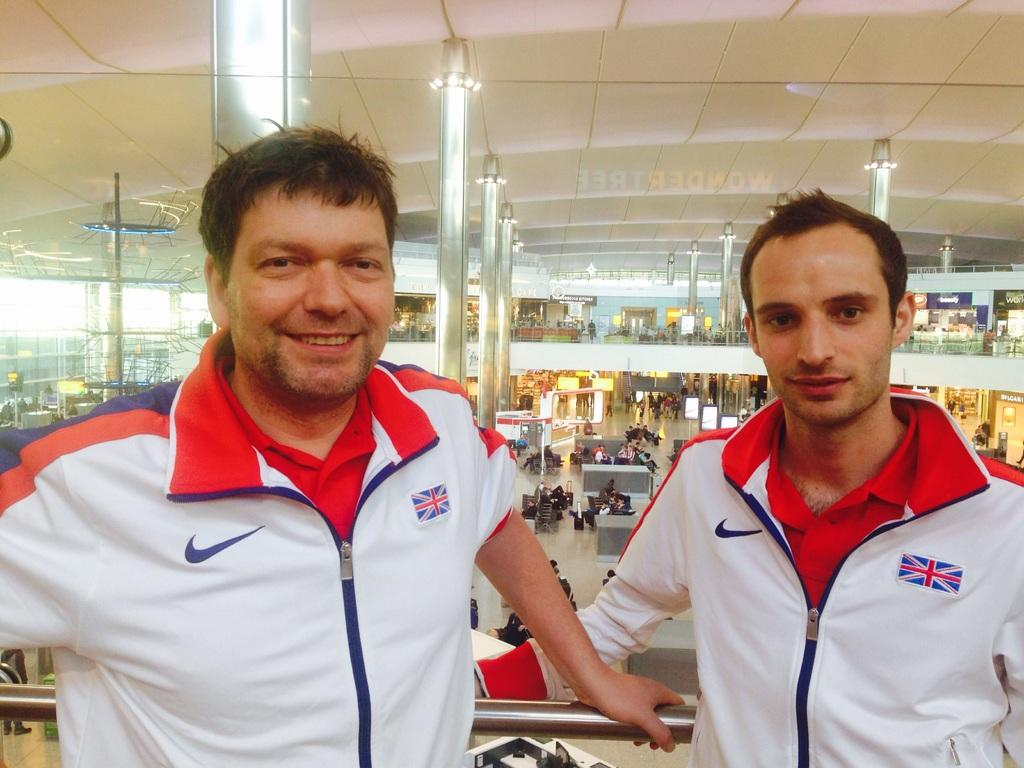How many men are in the image? There are two men in the image. What are the men wearing? The men are wearing jackets. What expression do the men have? The men are smiling. What can be seen in the background of the image? There are pillars, walls, objects, people, and shops in the background of the image. What is visible at the top of the image? There is a roof visible at the top of the image. Can you tell me how the stranger is trying to cover the quicksand in the image? There is no stranger or quicksand present in the image. 